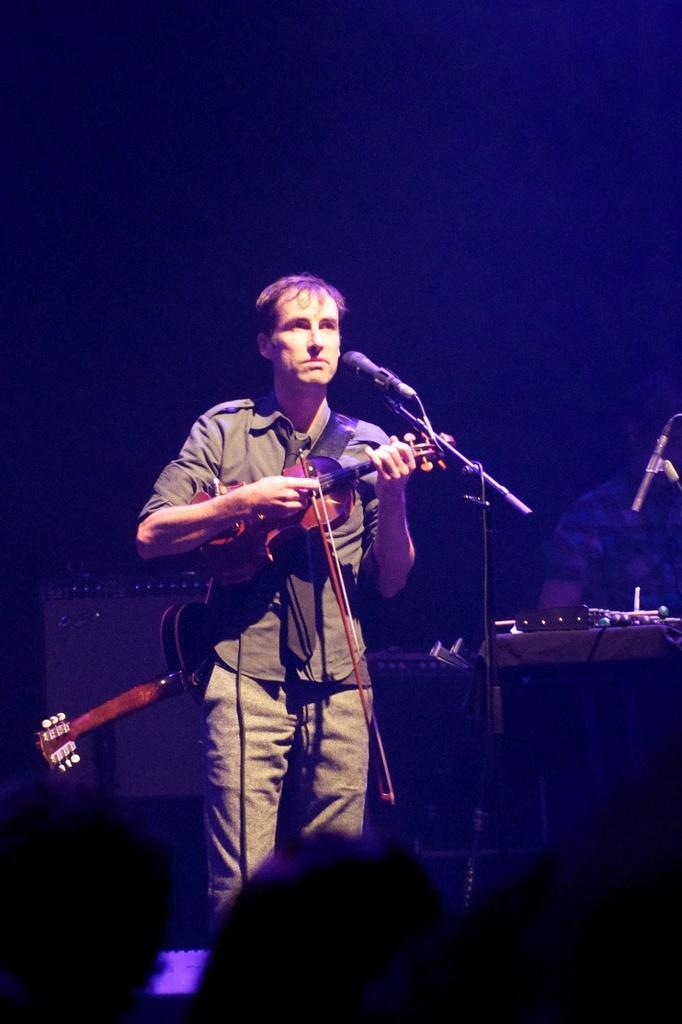How would you summarize this image in a sentence or two? The man is standing and is wearing a shirt. He is playing a violin. in front of him there is a mic. And at the back of him there is a guitar. Beside him there is a keyboard a person is playing it. 